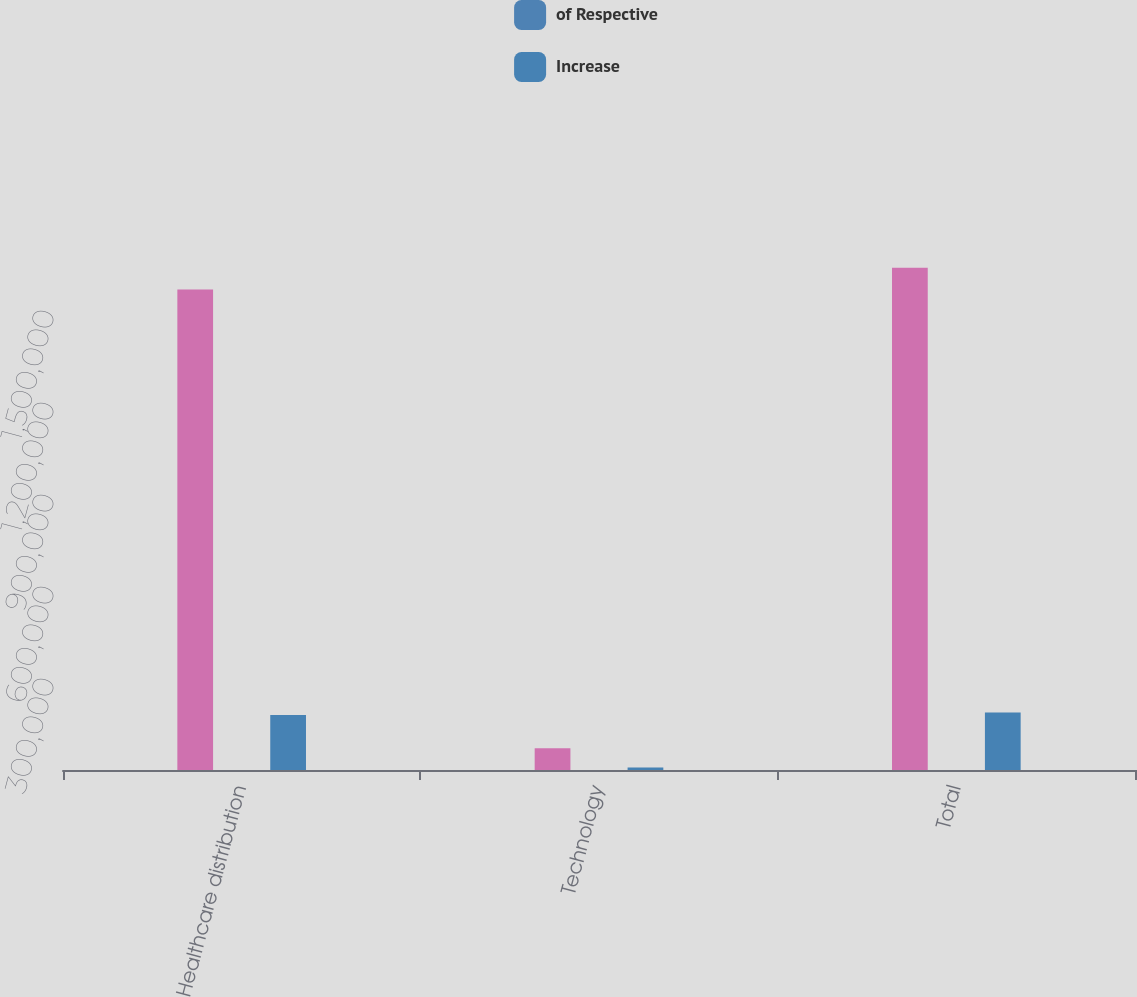Convert chart to OTSL. <chart><loc_0><loc_0><loc_500><loc_500><stacked_bar_chart><ecel><fcel>Healthcare distribution<fcel>Technology<fcel>Total<nl><fcel>nan<fcel>1.56692e+06<fcel>70545<fcel>1.63746e+06<nl><fcel>of Respective<fcel>21.4<fcel>35.3<fcel>21.8<nl><fcel>Increase<fcel>179334<fcel>8411<fcel>187745<nl></chart> 